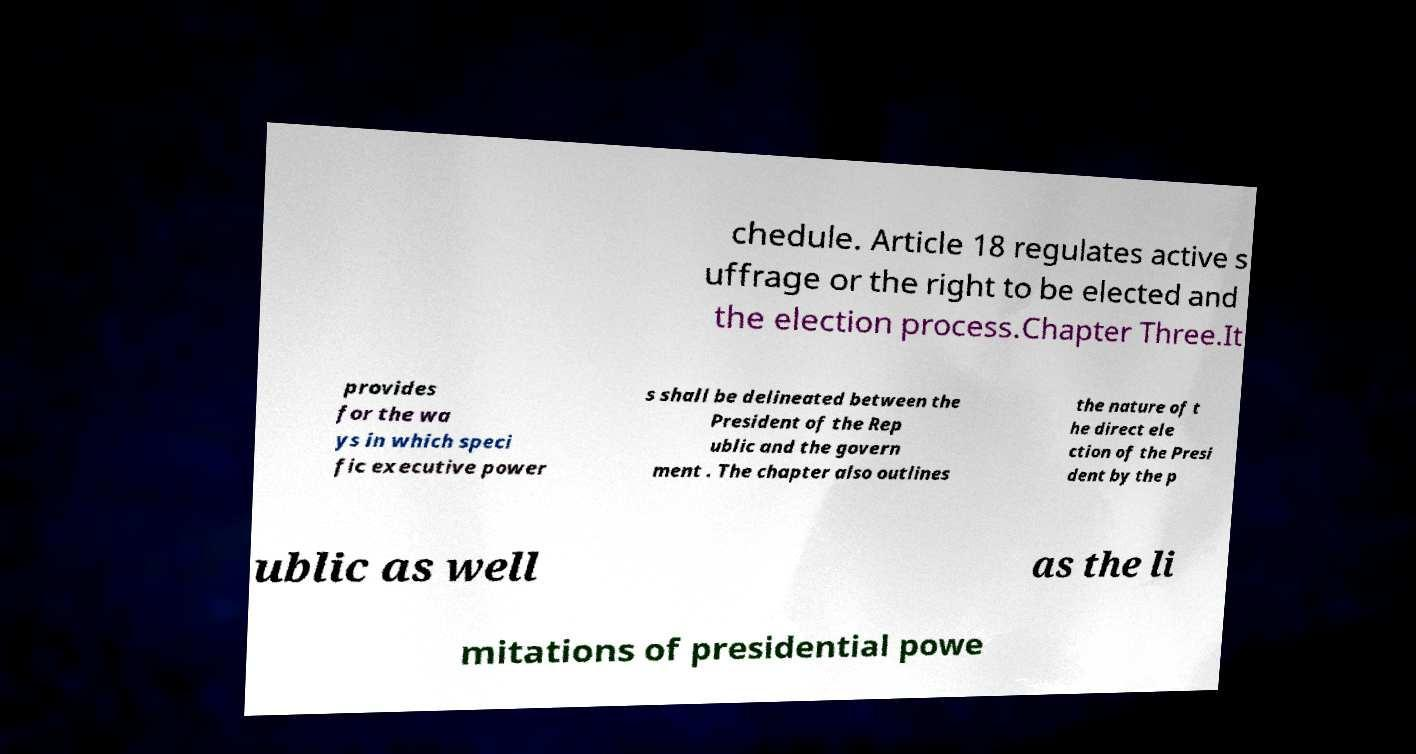Could you assist in decoding the text presented in this image and type it out clearly? chedule. Article 18 regulates active s uffrage or the right to be elected and the election process.Chapter Three.It provides for the wa ys in which speci fic executive power s shall be delineated between the President of the Rep ublic and the govern ment . The chapter also outlines the nature of t he direct ele ction of the Presi dent by the p ublic as well as the li mitations of presidential powe 